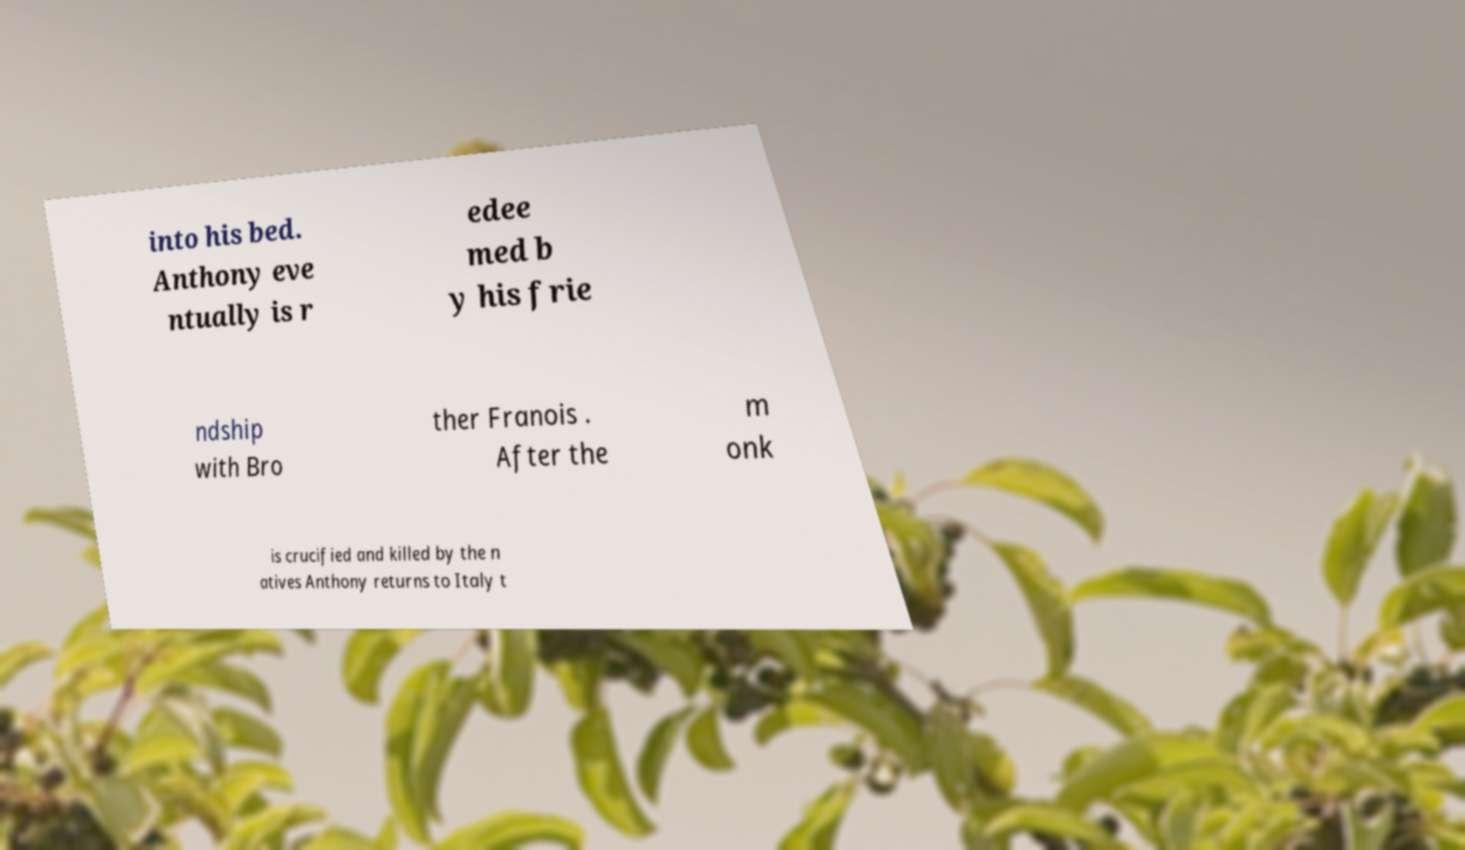For documentation purposes, I need the text within this image transcribed. Could you provide that? into his bed. Anthony eve ntually is r edee med b y his frie ndship with Bro ther Franois . After the m onk is crucified and killed by the n atives Anthony returns to Italy t 